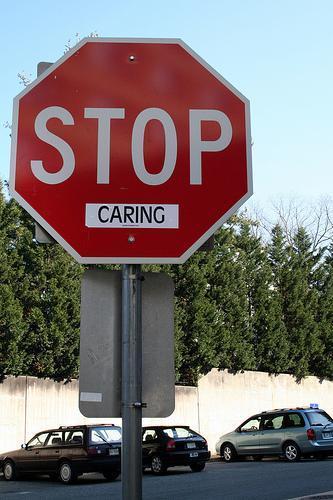How many STOP signs are in the photo?
Give a very brief answer. 1. 